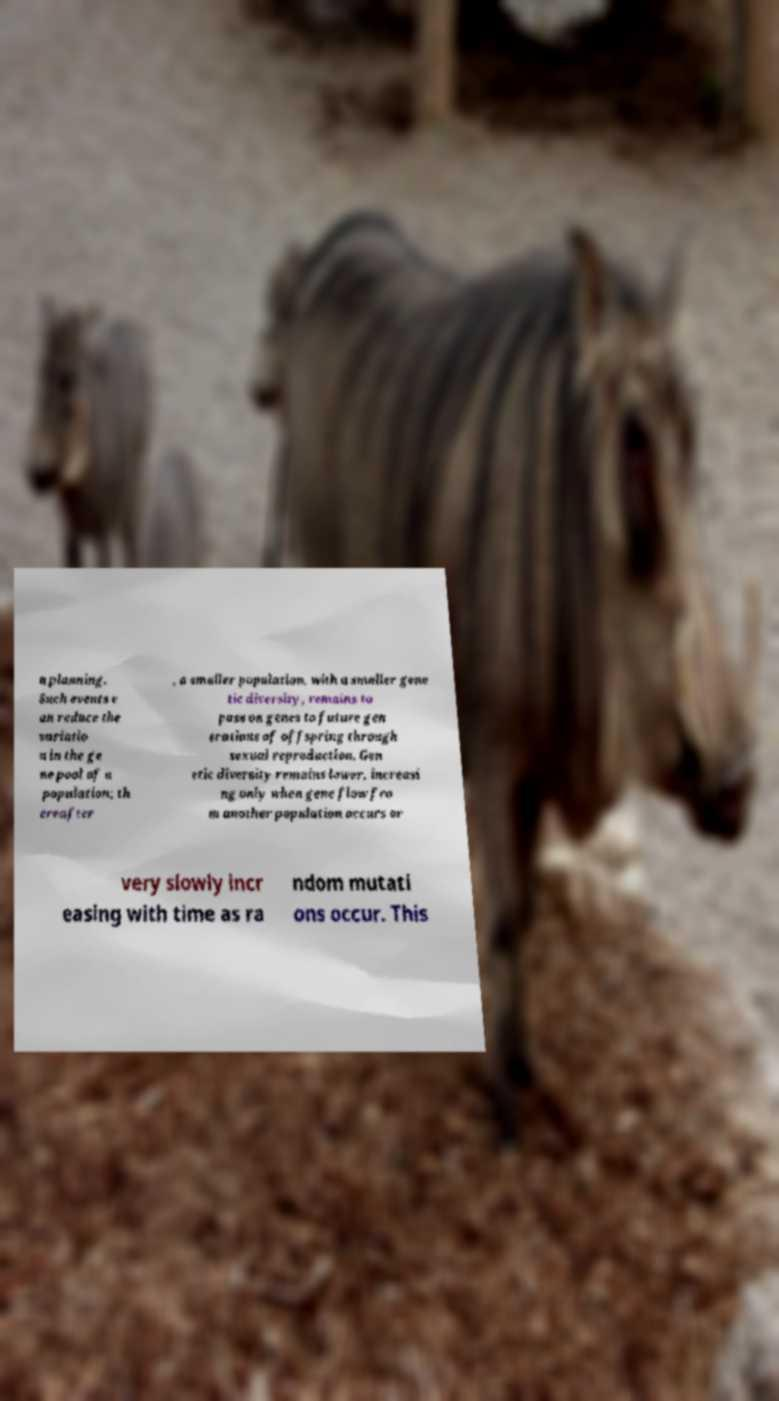Please identify and transcribe the text found in this image. n planning. Such events c an reduce the variatio n in the ge ne pool of a population; th ereafter , a smaller population, with a smaller gene tic diversity, remains to pass on genes to future gen erations of offspring through sexual reproduction. Gen etic diversity remains lower, increasi ng only when gene flow fro m another population occurs or very slowly incr easing with time as ra ndom mutati ons occur. This 